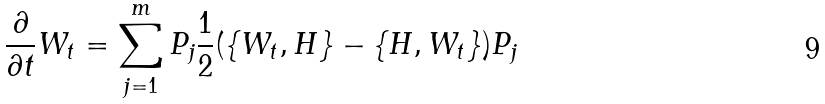<formula> <loc_0><loc_0><loc_500><loc_500>\frac { \partial } { \partial t } W _ { t } = \sum ^ { m } _ { j = 1 } P _ { j } \frac { 1 } { 2 } ( \{ W _ { t } , H \} - \{ H , W _ { t } \} ) P _ { j }</formula> 